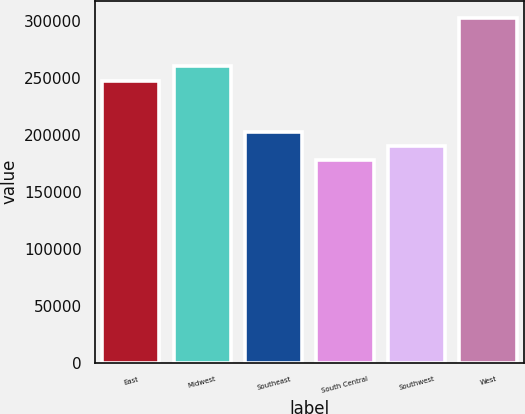Convert chart to OTSL. <chart><loc_0><loc_0><loc_500><loc_500><bar_chart><fcel>East<fcel>Midwest<fcel>Southeast<fcel>South Central<fcel>Southwest<fcel>West<nl><fcel>247400<fcel>260400<fcel>202900<fcel>177900<fcel>190400<fcel>302900<nl></chart> 